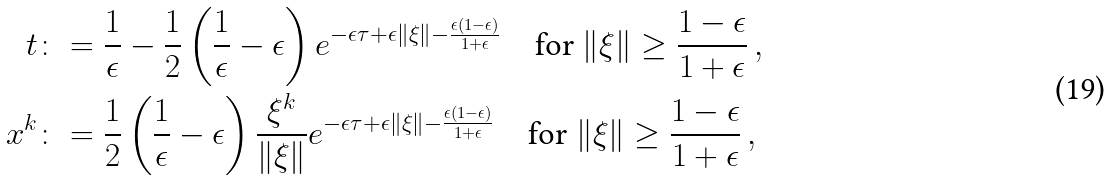<formula> <loc_0><loc_0><loc_500><loc_500>t & \colon = \frac { 1 } { \epsilon } - \frac { 1 } { 2 } \left ( \frac { 1 } { \epsilon } - \epsilon \right ) e ^ { - \epsilon \tau + \epsilon \| \xi \| - \frac { \epsilon ( 1 - \epsilon ) } { 1 + \epsilon } } \quad \text {for} \ \| \xi \| \geq \frac { 1 - \epsilon } { 1 + \epsilon } \, , \\ x ^ { k } & \colon = \frac { 1 } { 2 } \left ( \frac { 1 } { \epsilon } - \epsilon \right ) \frac { \xi ^ { k } } { \| \xi \| } e ^ { - \epsilon \tau + \epsilon \| \xi \| - \frac { \epsilon ( 1 - \epsilon ) } { 1 + \epsilon } } \quad \text {for} \ \| \xi \| \geq \frac { 1 - \epsilon } { 1 + \epsilon } \, ,</formula> 